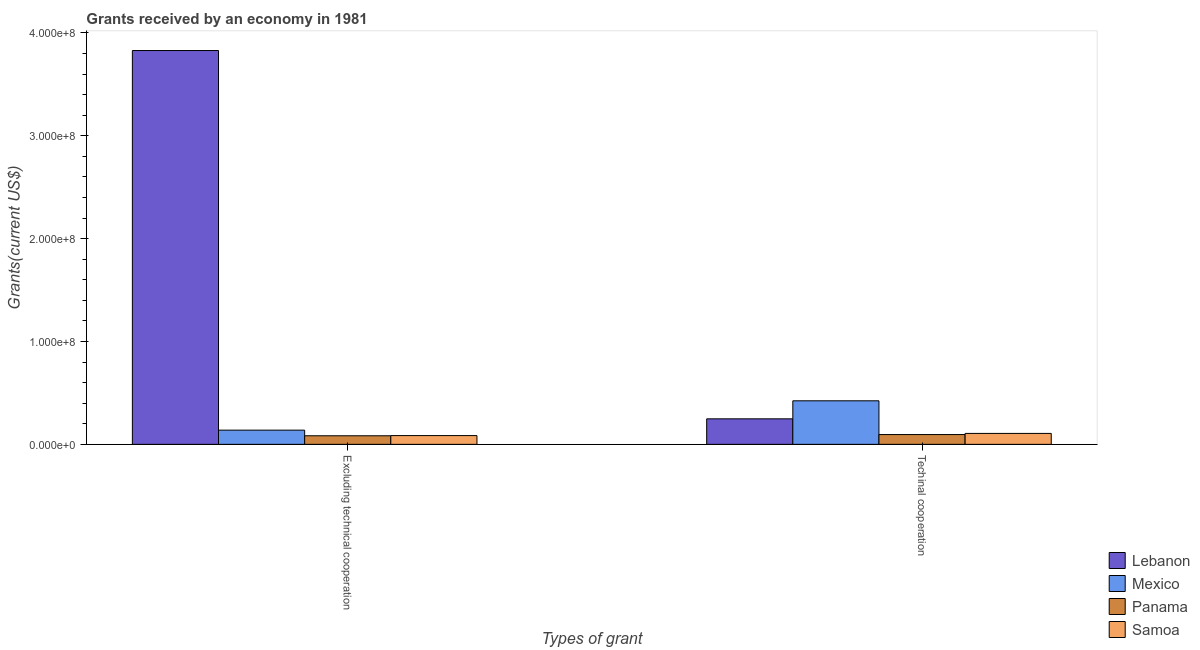How many groups of bars are there?
Offer a very short reply. 2. Are the number of bars per tick equal to the number of legend labels?
Your response must be concise. Yes. How many bars are there on the 1st tick from the left?
Give a very brief answer. 4. How many bars are there on the 2nd tick from the right?
Your answer should be very brief. 4. What is the label of the 2nd group of bars from the left?
Offer a very short reply. Techinal cooperation. What is the amount of grants received(including technical cooperation) in Panama?
Make the answer very short. 9.53e+06. Across all countries, what is the maximum amount of grants received(including technical cooperation)?
Ensure brevity in your answer.  4.23e+07. Across all countries, what is the minimum amount of grants received(excluding technical cooperation)?
Your response must be concise. 8.34e+06. In which country was the amount of grants received(excluding technical cooperation) maximum?
Your response must be concise. Lebanon. In which country was the amount of grants received(excluding technical cooperation) minimum?
Give a very brief answer. Panama. What is the total amount of grants received(including technical cooperation) in the graph?
Give a very brief answer. 8.73e+07. What is the difference between the amount of grants received(excluding technical cooperation) in Panama and that in Samoa?
Your response must be concise. -1.90e+05. What is the difference between the amount of grants received(including technical cooperation) in Samoa and the amount of grants received(excluding technical cooperation) in Mexico?
Make the answer very short. -3.17e+06. What is the average amount of grants received(including technical cooperation) per country?
Provide a succinct answer. 2.18e+07. What is the difference between the amount of grants received(excluding technical cooperation) and amount of grants received(including technical cooperation) in Lebanon?
Provide a succinct answer. 3.58e+08. What is the ratio of the amount of grants received(including technical cooperation) in Lebanon to that in Panama?
Offer a very short reply. 2.6. In how many countries, is the amount of grants received(including technical cooperation) greater than the average amount of grants received(including technical cooperation) taken over all countries?
Keep it short and to the point. 2. What does the 2nd bar from the right in Techinal cooperation represents?
Provide a short and direct response. Panama. How many countries are there in the graph?
Provide a succinct answer. 4. Does the graph contain any zero values?
Give a very brief answer. No. Where does the legend appear in the graph?
Give a very brief answer. Bottom right. How are the legend labels stacked?
Your answer should be compact. Vertical. What is the title of the graph?
Your answer should be compact. Grants received by an economy in 1981. Does "Chile" appear as one of the legend labels in the graph?
Offer a very short reply. No. What is the label or title of the X-axis?
Provide a succinct answer. Types of grant. What is the label or title of the Y-axis?
Offer a very short reply. Grants(current US$). What is the Grants(current US$) in Lebanon in Excluding technical cooperation?
Your answer should be compact. 3.83e+08. What is the Grants(current US$) of Mexico in Excluding technical cooperation?
Offer a terse response. 1.38e+07. What is the Grants(current US$) in Panama in Excluding technical cooperation?
Offer a terse response. 8.34e+06. What is the Grants(current US$) of Samoa in Excluding technical cooperation?
Make the answer very short. 8.53e+06. What is the Grants(current US$) of Lebanon in Techinal cooperation?
Provide a short and direct response. 2.48e+07. What is the Grants(current US$) in Mexico in Techinal cooperation?
Offer a very short reply. 4.23e+07. What is the Grants(current US$) in Panama in Techinal cooperation?
Provide a short and direct response. 9.53e+06. What is the Grants(current US$) in Samoa in Techinal cooperation?
Ensure brevity in your answer.  1.06e+07. Across all Types of grant, what is the maximum Grants(current US$) of Lebanon?
Your answer should be very brief. 3.83e+08. Across all Types of grant, what is the maximum Grants(current US$) in Mexico?
Offer a very short reply. 4.23e+07. Across all Types of grant, what is the maximum Grants(current US$) of Panama?
Your answer should be compact. 9.53e+06. Across all Types of grant, what is the maximum Grants(current US$) in Samoa?
Your answer should be very brief. 1.06e+07. Across all Types of grant, what is the minimum Grants(current US$) in Lebanon?
Give a very brief answer. 2.48e+07. Across all Types of grant, what is the minimum Grants(current US$) of Mexico?
Offer a very short reply. 1.38e+07. Across all Types of grant, what is the minimum Grants(current US$) in Panama?
Your answer should be very brief. 8.34e+06. Across all Types of grant, what is the minimum Grants(current US$) in Samoa?
Keep it short and to the point. 8.53e+06. What is the total Grants(current US$) of Lebanon in the graph?
Give a very brief answer. 4.08e+08. What is the total Grants(current US$) in Mexico in the graph?
Provide a succinct answer. 5.62e+07. What is the total Grants(current US$) in Panama in the graph?
Your answer should be compact. 1.79e+07. What is the total Grants(current US$) in Samoa in the graph?
Keep it short and to the point. 1.92e+07. What is the difference between the Grants(current US$) in Lebanon in Excluding technical cooperation and that in Techinal cooperation?
Ensure brevity in your answer.  3.58e+08. What is the difference between the Grants(current US$) of Mexico in Excluding technical cooperation and that in Techinal cooperation?
Give a very brief answer. -2.85e+07. What is the difference between the Grants(current US$) of Panama in Excluding technical cooperation and that in Techinal cooperation?
Your answer should be very brief. -1.19e+06. What is the difference between the Grants(current US$) of Samoa in Excluding technical cooperation and that in Techinal cooperation?
Your answer should be compact. -2.11e+06. What is the difference between the Grants(current US$) of Lebanon in Excluding technical cooperation and the Grants(current US$) of Mexico in Techinal cooperation?
Provide a short and direct response. 3.41e+08. What is the difference between the Grants(current US$) in Lebanon in Excluding technical cooperation and the Grants(current US$) in Panama in Techinal cooperation?
Ensure brevity in your answer.  3.73e+08. What is the difference between the Grants(current US$) in Lebanon in Excluding technical cooperation and the Grants(current US$) in Samoa in Techinal cooperation?
Your answer should be very brief. 3.72e+08. What is the difference between the Grants(current US$) of Mexico in Excluding technical cooperation and the Grants(current US$) of Panama in Techinal cooperation?
Offer a very short reply. 4.28e+06. What is the difference between the Grants(current US$) of Mexico in Excluding technical cooperation and the Grants(current US$) of Samoa in Techinal cooperation?
Ensure brevity in your answer.  3.17e+06. What is the difference between the Grants(current US$) of Panama in Excluding technical cooperation and the Grants(current US$) of Samoa in Techinal cooperation?
Give a very brief answer. -2.30e+06. What is the average Grants(current US$) of Lebanon per Types of grant?
Offer a very short reply. 2.04e+08. What is the average Grants(current US$) in Mexico per Types of grant?
Provide a succinct answer. 2.81e+07. What is the average Grants(current US$) in Panama per Types of grant?
Your response must be concise. 8.94e+06. What is the average Grants(current US$) of Samoa per Types of grant?
Your answer should be very brief. 9.58e+06. What is the difference between the Grants(current US$) in Lebanon and Grants(current US$) in Mexico in Excluding technical cooperation?
Your response must be concise. 3.69e+08. What is the difference between the Grants(current US$) of Lebanon and Grants(current US$) of Panama in Excluding technical cooperation?
Your answer should be compact. 3.75e+08. What is the difference between the Grants(current US$) of Lebanon and Grants(current US$) of Samoa in Excluding technical cooperation?
Ensure brevity in your answer.  3.74e+08. What is the difference between the Grants(current US$) of Mexico and Grants(current US$) of Panama in Excluding technical cooperation?
Give a very brief answer. 5.47e+06. What is the difference between the Grants(current US$) in Mexico and Grants(current US$) in Samoa in Excluding technical cooperation?
Give a very brief answer. 5.28e+06. What is the difference between the Grants(current US$) of Panama and Grants(current US$) of Samoa in Excluding technical cooperation?
Make the answer very short. -1.90e+05. What is the difference between the Grants(current US$) in Lebanon and Grants(current US$) in Mexico in Techinal cooperation?
Make the answer very short. -1.75e+07. What is the difference between the Grants(current US$) of Lebanon and Grants(current US$) of Panama in Techinal cooperation?
Provide a succinct answer. 1.53e+07. What is the difference between the Grants(current US$) in Lebanon and Grants(current US$) in Samoa in Techinal cooperation?
Offer a very short reply. 1.42e+07. What is the difference between the Grants(current US$) in Mexico and Grants(current US$) in Panama in Techinal cooperation?
Keep it short and to the point. 3.28e+07. What is the difference between the Grants(current US$) in Mexico and Grants(current US$) in Samoa in Techinal cooperation?
Make the answer very short. 3.17e+07. What is the difference between the Grants(current US$) of Panama and Grants(current US$) of Samoa in Techinal cooperation?
Offer a terse response. -1.11e+06. What is the ratio of the Grants(current US$) in Lebanon in Excluding technical cooperation to that in Techinal cooperation?
Ensure brevity in your answer.  15.43. What is the ratio of the Grants(current US$) of Mexico in Excluding technical cooperation to that in Techinal cooperation?
Provide a succinct answer. 0.33. What is the ratio of the Grants(current US$) of Panama in Excluding technical cooperation to that in Techinal cooperation?
Offer a terse response. 0.88. What is the ratio of the Grants(current US$) of Samoa in Excluding technical cooperation to that in Techinal cooperation?
Offer a terse response. 0.8. What is the difference between the highest and the second highest Grants(current US$) in Lebanon?
Your response must be concise. 3.58e+08. What is the difference between the highest and the second highest Grants(current US$) in Mexico?
Give a very brief answer. 2.85e+07. What is the difference between the highest and the second highest Grants(current US$) in Panama?
Make the answer very short. 1.19e+06. What is the difference between the highest and the second highest Grants(current US$) in Samoa?
Keep it short and to the point. 2.11e+06. What is the difference between the highest and the lowest Grants(current US$) in Lebanon?
Give a very brief answer. 3.58e+08. What is the difference between the highest and the lowest Grants(current US$) of Mexico?
Offer a terse response. 2.85e+07. What is the difference between the highest and the lowest Grants(current US$) of Panama?
Offer a very short reply. 1.19e+06. What is the difference between the highest and the lowest Grants(current US$) in Samoa?
Your answer should be very brief. 2.11e+06. 